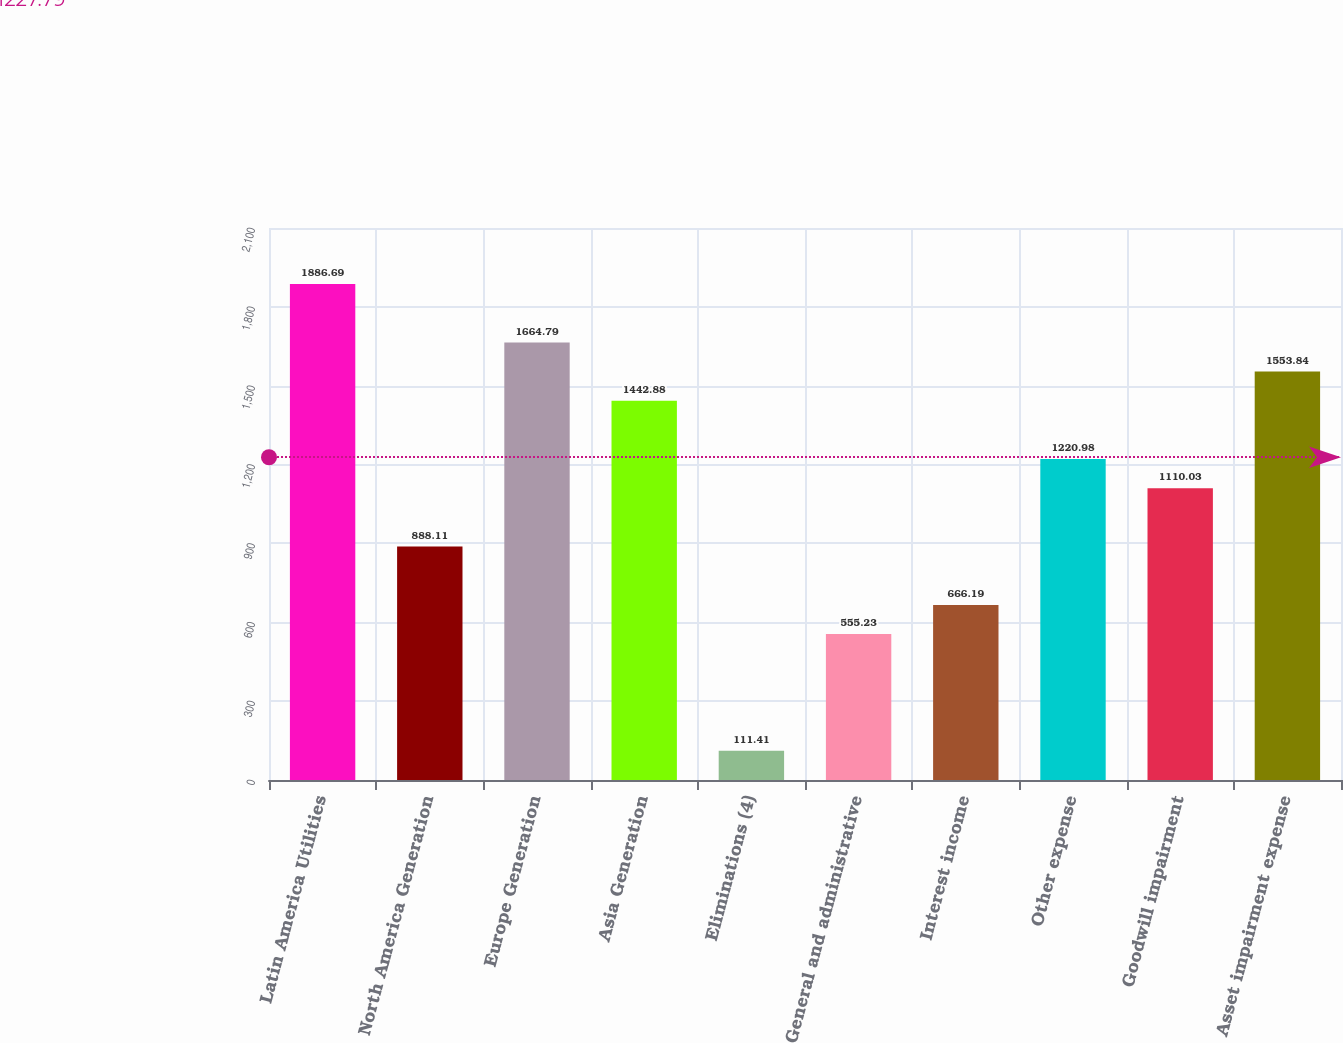Convert chart. <chart><loc_0><loc_0><loc_500><loc_500><bar_chart><fcel>Latin America Utilities<fcel>North America Generation<fcel>Europe Generation<fcel>Asia Generation<fcel>Eliminations (4)<fcel>General and administrative<fcel>Interest income<fcel>Other expense<fcel>Goodwill impairment<fcel>Asset impairment expense<nl><fcel>1886.69<fcel>888.11<fcel>1664.79<fcel>1442.88<fcel>111.41<fcel>555.23<fcel>666.19<fcel>1220.98<fcel>1110.03<fcel>1553.84<nl></chart> 